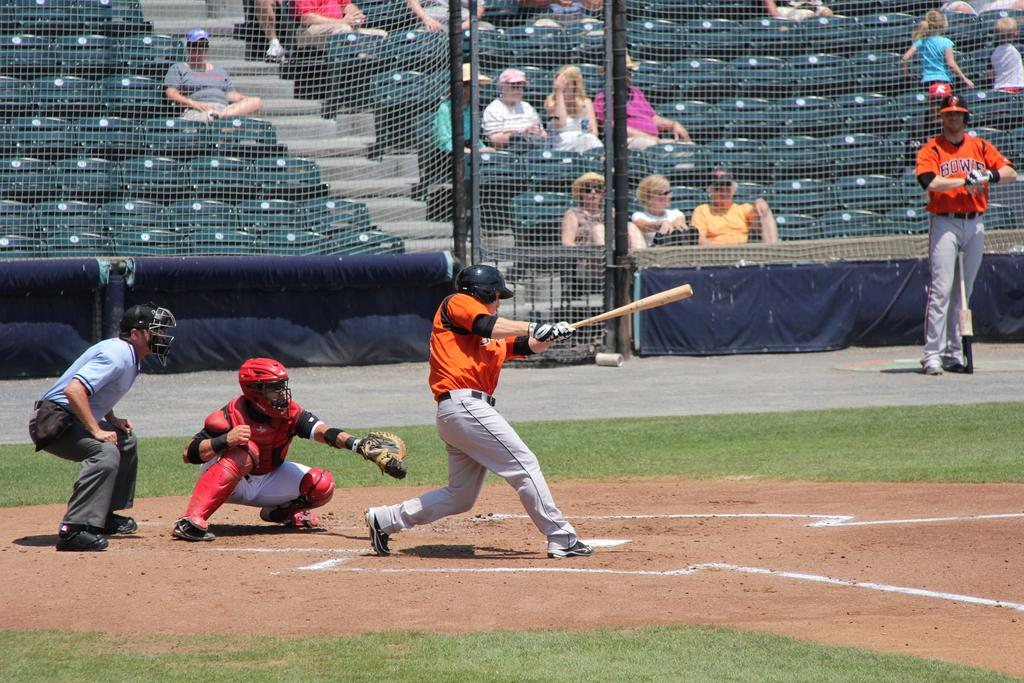<image>
Summarize the visual content of the image. The letters bow are visible on a baseball players uniform. 